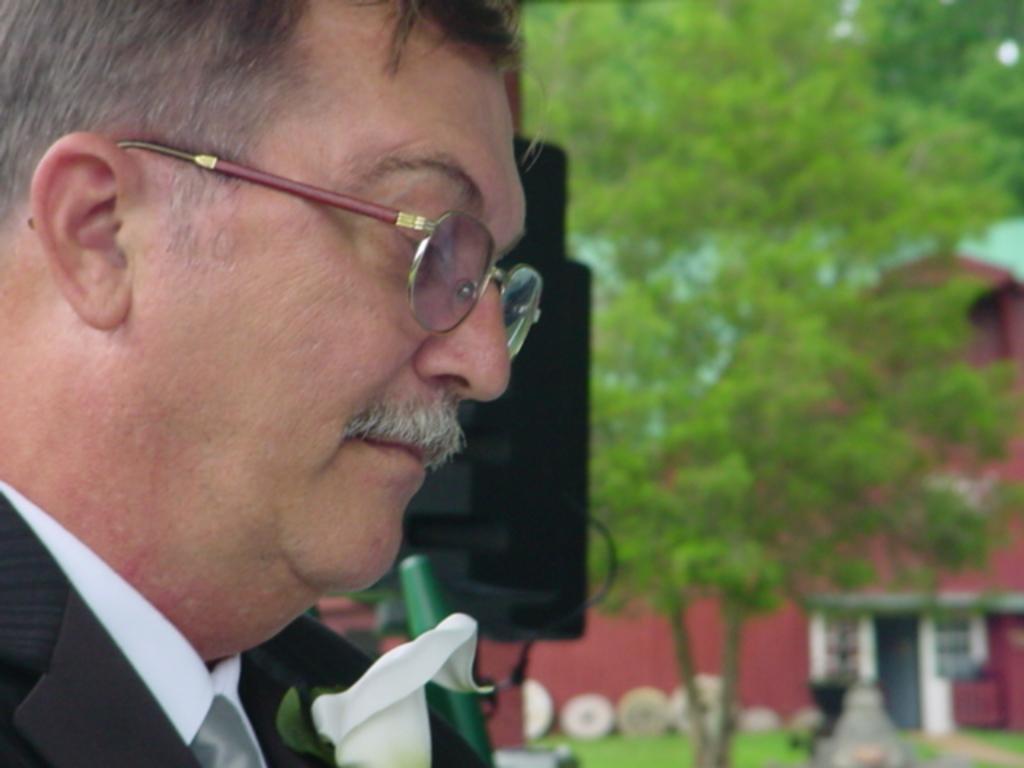Can you describe this image briefly? This image consists of a man wearing black suit and white shirt. On the right, we can see a tree along with a building. At the bottom, there is green grass. Beside him, it looks like a speaker. 